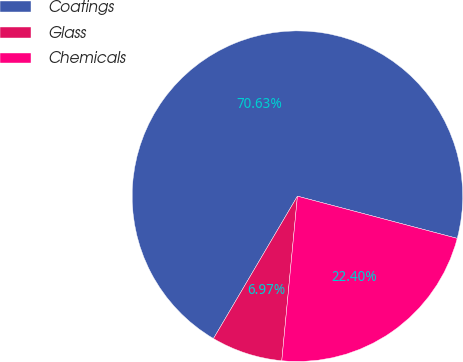<chart> <loc_0><loc_0><loc_500><loc_500><pie_chart><fcel>Coatings<fcel>Glass<fcel>Chemicals<nl><fcel>70.63%<fcel>6.97%<fcel>22.4%<nl></chart> 